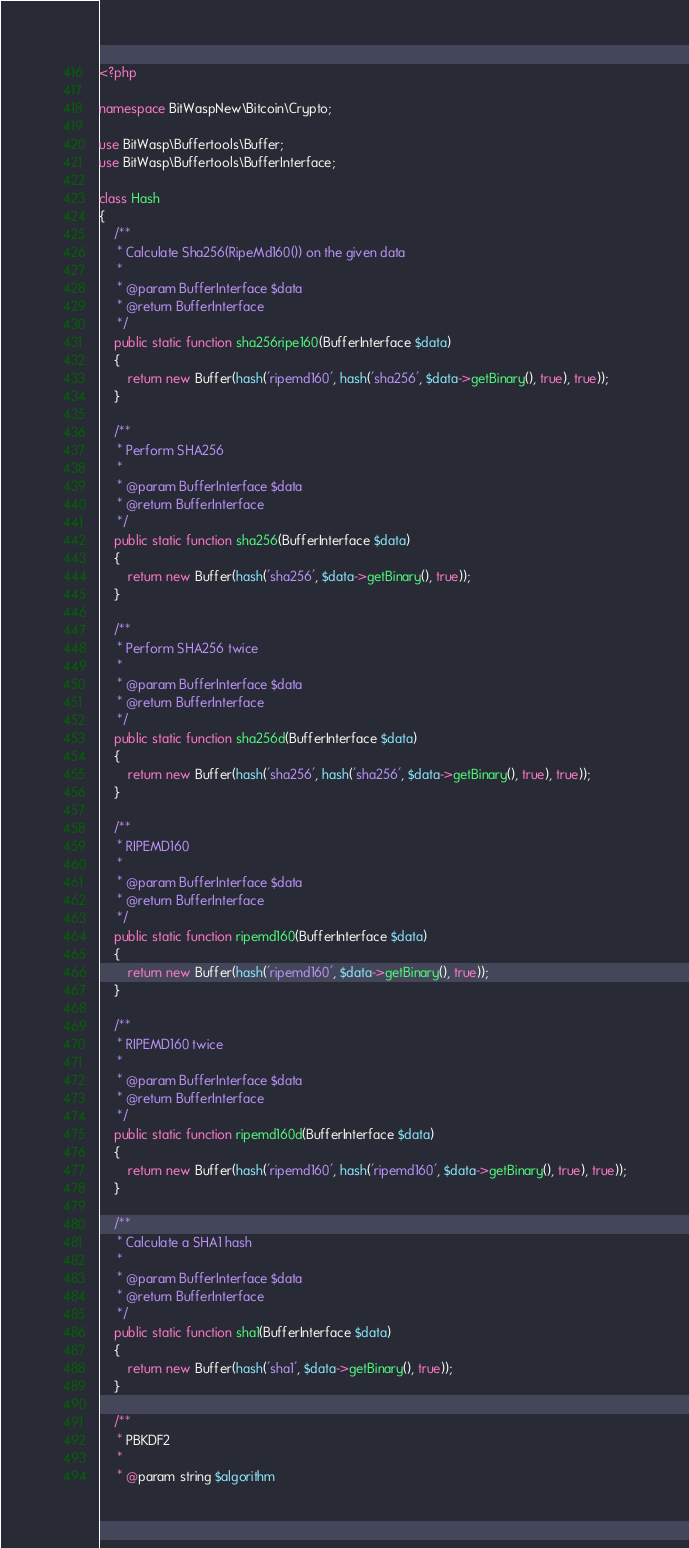<code> <loc_0><loc_0><loc_500><loc_500><_PHP_><?php

namespace BitWaspNew\Bitcoin\Crypto;

use BitWasp\Buffertools\Buffer;
use BitWasp\Buffertools\BufferInterface;

class Hash
{
    /**
     * Calculate Sha256(RipeMd160()) on the given data
     *
     * @param BufferInterface $data
     * @return BufferInterface
     */
    public static function sha256ripe160(BufferInterface $data)
    {
        return new Buffer(hash('ripemd160', hash('sha256', $data->getBinary(), true), true));
    }

    /**
     * Perform SHA256
     *
     * @param BufferInterface $data
     * @return BufferInterface
     */
    public static function sha256(BufferInterface $data)
    {
        return new Buffer(hash('sha256', $data->getBinary(), true));
    }

    /**
     * Perform SHA256 twice
     *
     * @param BufferInterface $data
     * @return BufferInterface
     */
    public static function sha256d(BufferInterface $data)
    {
        return new Buffer(hash('sha256', hash('sha256', $data->getBinary(), true), true));
    }

    /**
     * RIPEMD160
     *
     * @param BufferInterface $data
     * @return BufferInterface
     */
    public static function ripemd160(BufferInterface $data)
    {
        return new Buffer(hash('ripemd160', $data->getBinary(), true));
    }

    /**
     * RIPEMD160 twice
     *
     * @param BufferInterface $data
     * @return BufferInterface
     */
    public static function ripemd160d(BufferInterface $data)
    {
        return new Buffer(hash('ripemd160', hash('ripemd160', $data->getBinary(), true), true));
    }

    /**
     * Calculate a SHA1 hash
     *
     * @param BufferInterface $data
     * @return BufferInterface
     */
    public static function sha1(BufferInterface $data)
    {
        return new Buffer(hash('sha1', $data->getBinary(), true));
    }

    /**
     * PBKDF2
     *
     * @param string $algorithm</code> 